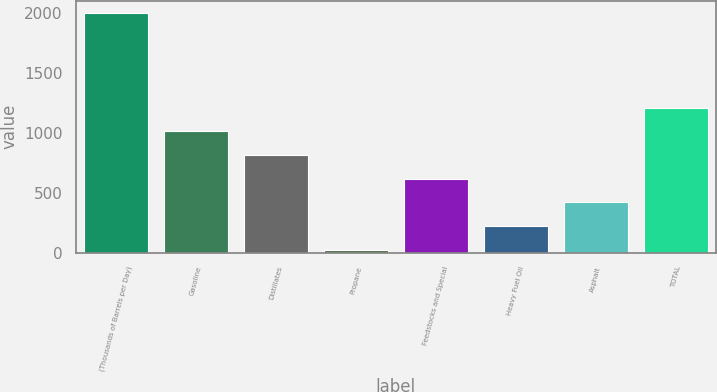<chart> <loc_0><loc_0><loc_500><loc_500><bar_chart><fcel>(Thousands of Barrels per Day)<fcel>Gasoline<fcel>Distillates<fcel>Propane<fcel>Feedstocks and Special<fcel>Heavy Fuel Oil<fcel>Asphalt<fcel>TOTAL<nl><fcel>2004<fcel>1013<fcel>814.8<fcel>22<fcel>616.6<fcel>220.2<fcel>418.4<fcel>1211.2<nl></chart> 